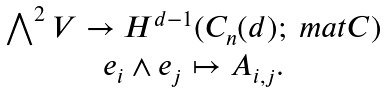<formula> <loc_0><loc_0><loc_500><loc_500>\begin{array} { c } \bigwedge ^ { 2 } V \to H ^ { d - 1 } ( C _ { n } ( d ) ; \ m a t C ) \\ e _ { i } \wedge e _ { j } \mapsto A _ { i , j } . \end{array}</formula> 